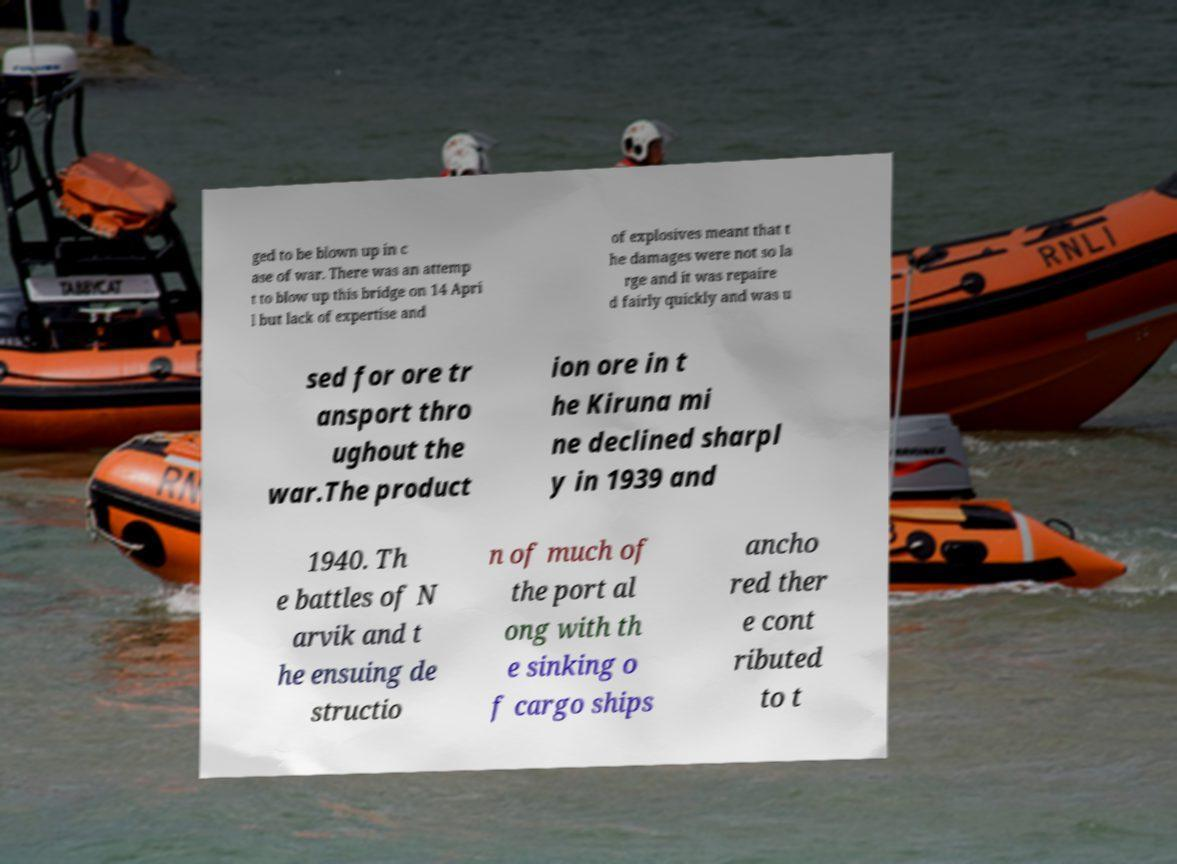Can you accurately transcribe the text from the provided image for me? ged to be blown up in c ase of war. There was an attemp t to blow up this bridge on 14 Apri l but lack of expertise and of explosives meant that t he damages were not so la rge and it was repaire d fairly quickly and was u sed for ore tr ansport thro ughout the war.The product ion ore in t he Kiruna mi ne declined sharpl y in 1939 and 1940. Th e battles of N arvik and t he ensuing de structio n of much of the port al ong with th e sinking o f cargo ships ancho red ther e cont ributed to t 